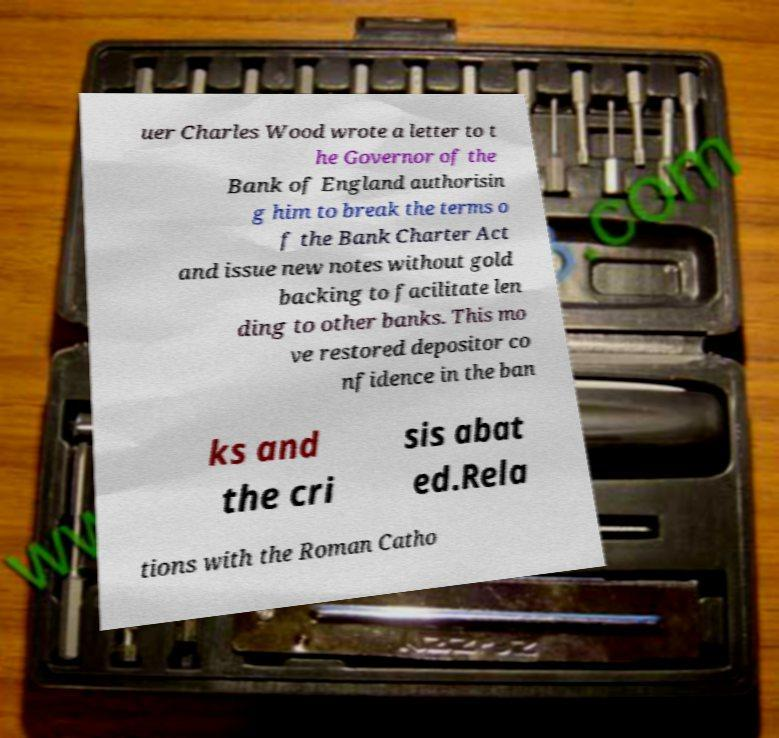Please read and relay the text visible in this image. What does it say? uer Charles Wood wrote a letter to t he Governor of the Bank of England authorisin g him to break the terms o f the Bank Charter Act and issue new notes without gold backing to facilitate len ding to other banks. This mo ve restored depositor co nfidence in the ban ks and the cri sis abat ed.Rela tions with the Roman Catho 